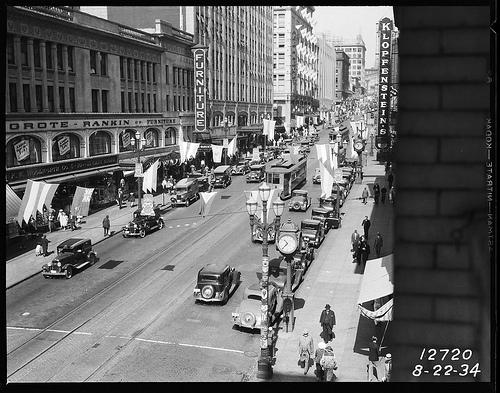What is in the street? Please explain your reasoning. cars. There are cars in the street. 